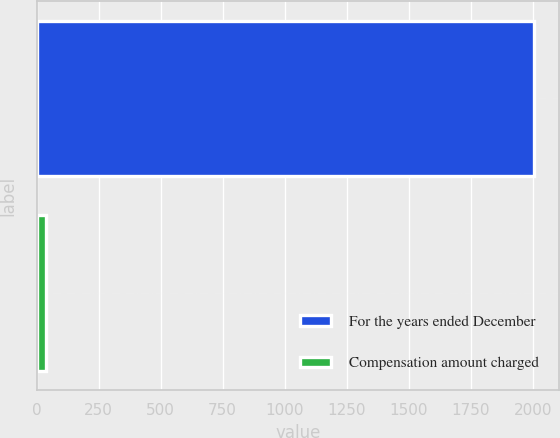<chart> <loc_0><loc_0><loc_500><loc_500><bar_chart><fcel>For the years ended December<fcel>Compensation amount charged<nl><fcel>2005<fcel>38.2<nl></chart> 